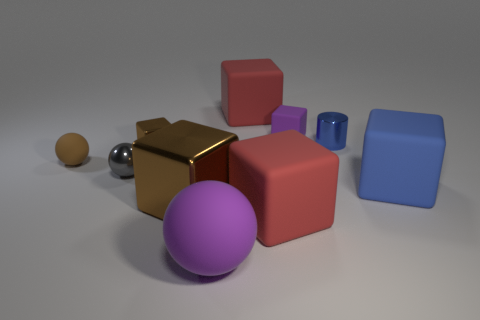What is the material of the blue thing that is the same size as the purple sphere?
Provide a succinct answer. Rubber. There is a large cube to the right of the small metal cylinder; what color is it?
Provide a short and direct response. Blue. How many red rubber objects are there?
Give a very brief answer. 2. There is a large matte cube that is behind the brown metallic thing that is to the left of the big brown object; are there any large matte cubes left of it?
Your answer should be compact. No. There is a brown rubber object that is the same size as the purple cube; what is its shape?
Make the answer very short. Sphere. What number of other objects are there of the same color as the small metallic ball?
Make the answer very short. 0. What is the material of the large purple sphere?
Provide a short and direct response. Rubber. What number of other things are there of the same material as the tiny purple block
Your answer should be very brief. 5. There is a thing that is in front of the big blue matte thing and to the right of the big purple rubber sphere; what size is it?
Offer a terse response. Large. There is a big blue matte thing to the right of the large red block that is behind the small shiny ball; what is its shape?
Provide a short and direct response. Cube. 